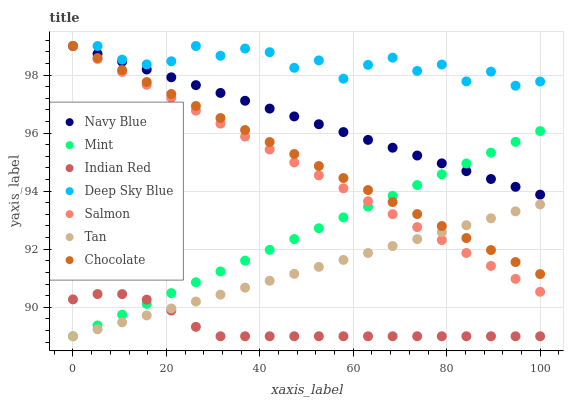Does Indian Red have the minimum area under the curve?
Answer yes or no. Yes. Does Deep Sky Blue have the maximum area under the curve?
Answer yes or no. Yes. Does Navy Blue have the minimum area under the curve?
Answer yes or no. No. Does Navy Blue have the maximum area under the curve?
Answer yes or no. No. Is Navy Blue the smoothest?
Answer yes or no. Yes. Is Deep Sky Blue the roughest?
Answer yes or no. Yes. Is Salmon the smoothest?
Answer yes or no. No. Is Salmon the roughest?
Answer yes or no. No. Does Indian Red have the lowest value?
Answer yes or no. Yes. Does Navy Blue have the lowest value?
Answer yes or no. No. Does Deep Sky Blue have the highest value?
Answer yes or no. Yes. Does Tan have the highest value?
Answer yes or no. No. Is Mint less than Deep Sky Blue?
Answer yes or no. Yes. Is Salmon greater than Indian Red?
Answer yes or no. Yes. Does Navy Blue intersect Mint?
Answer yes or no. Yes. Is Navy Blue less than Mint?
Answer yes or no. No. Is Navy Blue greater than Mint?
Answer yes or no. No. Does Mint intersect Deep Sky Blue?
Answer yes or no. No. 